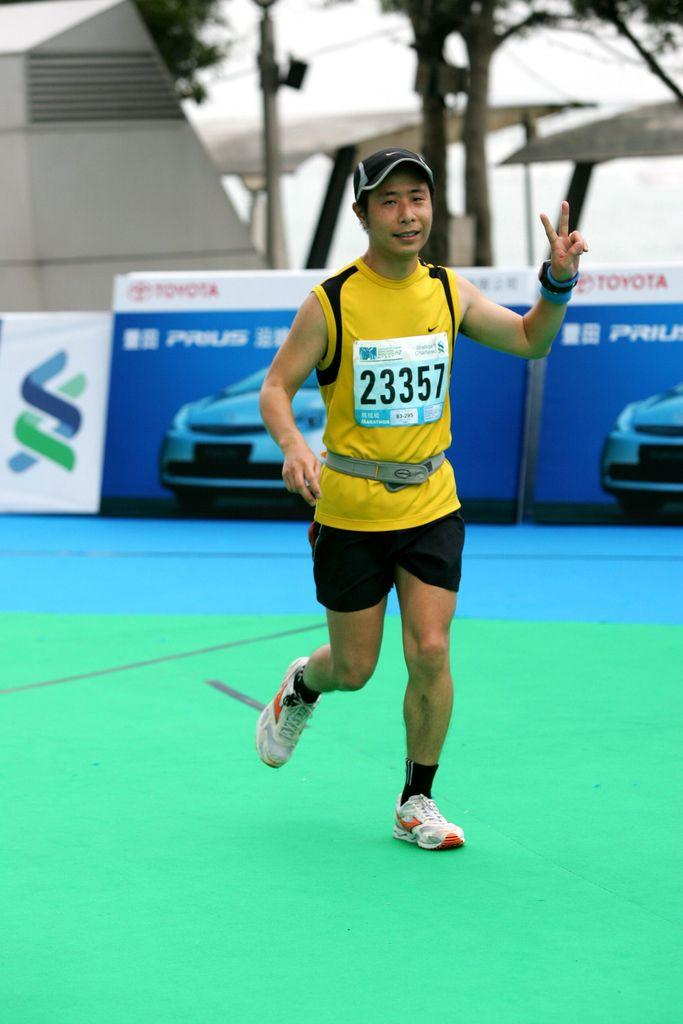What is the person in the image wearing on their upper body? The person is wearing a yellow T-shirt. What type of headwear is the person wearing? The person is wearing a cap. What accessory is the person wearing on their wrist? The person is wearing a watch. What type of footwear is the person wearing? The person is wearing shoes. What is the person's position in the image? The person is on the ground. What can be seen in the background of the image? There are boards, a wall, tents, and trees in the background of the image. What type of roof is visible on the tents in the image? There is no roof visible on the tents in the image; they are open structures. What type of leather is the person wearing in the image? The person is not wearing any leather in the image. What type of lipstick is the person wearing in the image? There is no indication that the person is wearing lipstick in the image. 